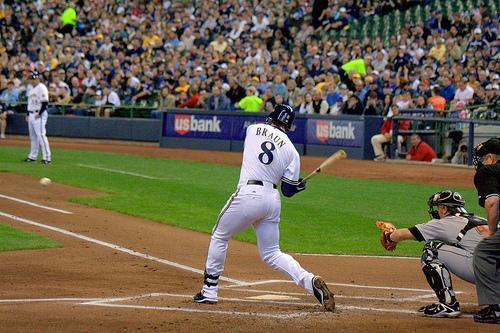How many men on the field?
Give a very brief answer. 3. How many baseball players are using a fielding glove?
Give a very brief answer. 1. 